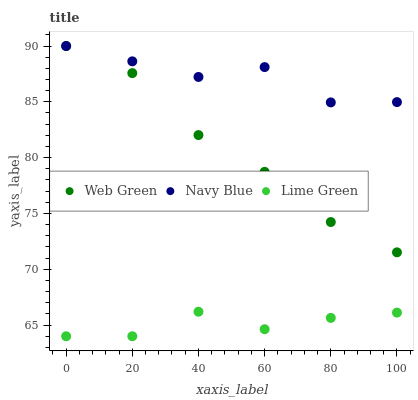Does Lime Green have the minimum area under the curve?
Answer yes or no. Yes. Does Navy Blue have the maximum area under the curve?
Answer yes or no. Yes. Does Web Green have the minimum area under the curve?
Answer yes or no. No. Does Web Green have the maximum area under the curve?
Answer yes or no. No. Is Web Green the smoothest?
Answer yes or no. Yes. Is Navy Blue the roughest?
Answer yes or no. Yes. Is Lime Green the smoothest?
Answer yes or no. No. Is Lime Green the roughest?
Answer yes or no. No. Does Lime Green have the lowest value?
Answer yes or no. Yes. Does Web Green have the lowest value?
Answer yes or no. No. Does Web Green have the highest value?
Answer yes or no. Yes. Does Lime Green have the highest value?
Answer yes or no. No. Is Lime Green less than Navy Blue?
Answer yes or no. Yes. Is Navy Blue greater than Lime Green?
Answer yes or no. Yes. Does Web Green intersect Navy Blue?
Answer yes or no. Yes. Is Web Green less than Navy Blue?
Answer yes or no. No. Is Web Green greater than Navy Blue?
Answer yes or no. No. Does Lime Green intersect Navy Blue?
Answer yes or no. No. 